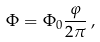Convert formula to latex. <formula><loc_0><loc_0><loc_500><loc_500>\Phi = \Phi _ { 0 } { \frac { \varphi } { 2 \pi } } \, ,</formula> 